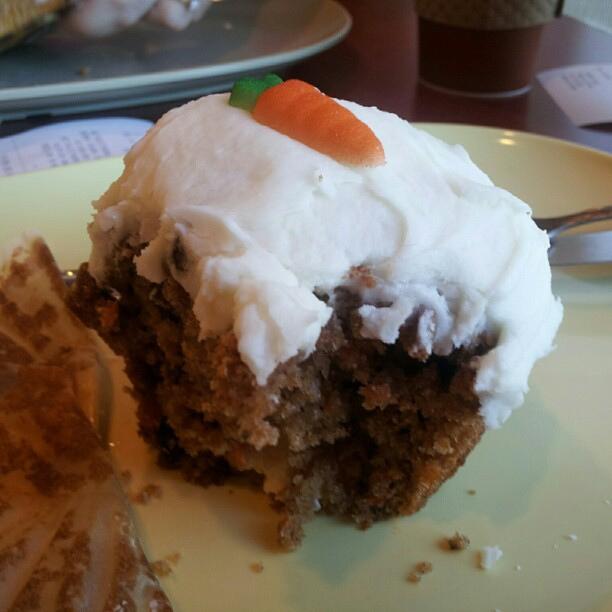What type of cake is that?
Concise answer only. Carrot. What is on the plate?
Keep it brief. Carrot cake. Can the diner use ketchup?
Write a very short answer. No. Will this desert melt?
Concise answer only. No. Are there multiple layers to the desert?
Quick response, please. No. Does this contain chickpeas?
Write a very short answer. No. Has anyone started eating this dish yet?
Be succinct. Yes. What is that?
Answer briefly. Carrot cake. What kind of cake is on the plate?
Keep it brief. Carrot. Are there any vegetables in the pastry?
Answer briefly. Yes. Is there a bite out of the cupcake?
Quick response, please. Yes. What is this dessert?
Write a very short answer. Carrot cake. Are there potatoes on the plate?
Concise answer only. No. What is covering the outside of the bun?
Concise answer only. Frosting. Is this a piece of cake?
Write a very short answer. Yes. What color is the frosting?
Be succinct. White. Is this selection part of the dessert menu?
Keep it brief. Yes. What kind of food is on the plate?
Write a very short answer. Carrot cake. What kind of cheese is on the food?
Short answer required. Cream. What is to the right of the bun?
Write a very short answer. Cake. Is this a nutritious meal?
Give a very brief answer. No. Which of these foods would Bugs Bunny like best?
Write a very short answer. Carrot. Did someone take a bite of the desert?
Answer briefly. Yes. What is the orange food?
Give a very brief answer. Carrot. What is this?
Write a very short answer. Cake. Where is the desert located?
Concise answer only. On plate. Is the cake sliced?
Be succinct. No. What is in the inside of the donut?
Concise answer only. Carrot cake. Is there more than one food group on the plate?
Keep it brief. No. What is the white stuff on the pastries?
Answer briefly. Frosting. What is the surface of the table?
Write a very short answer. Wood. 